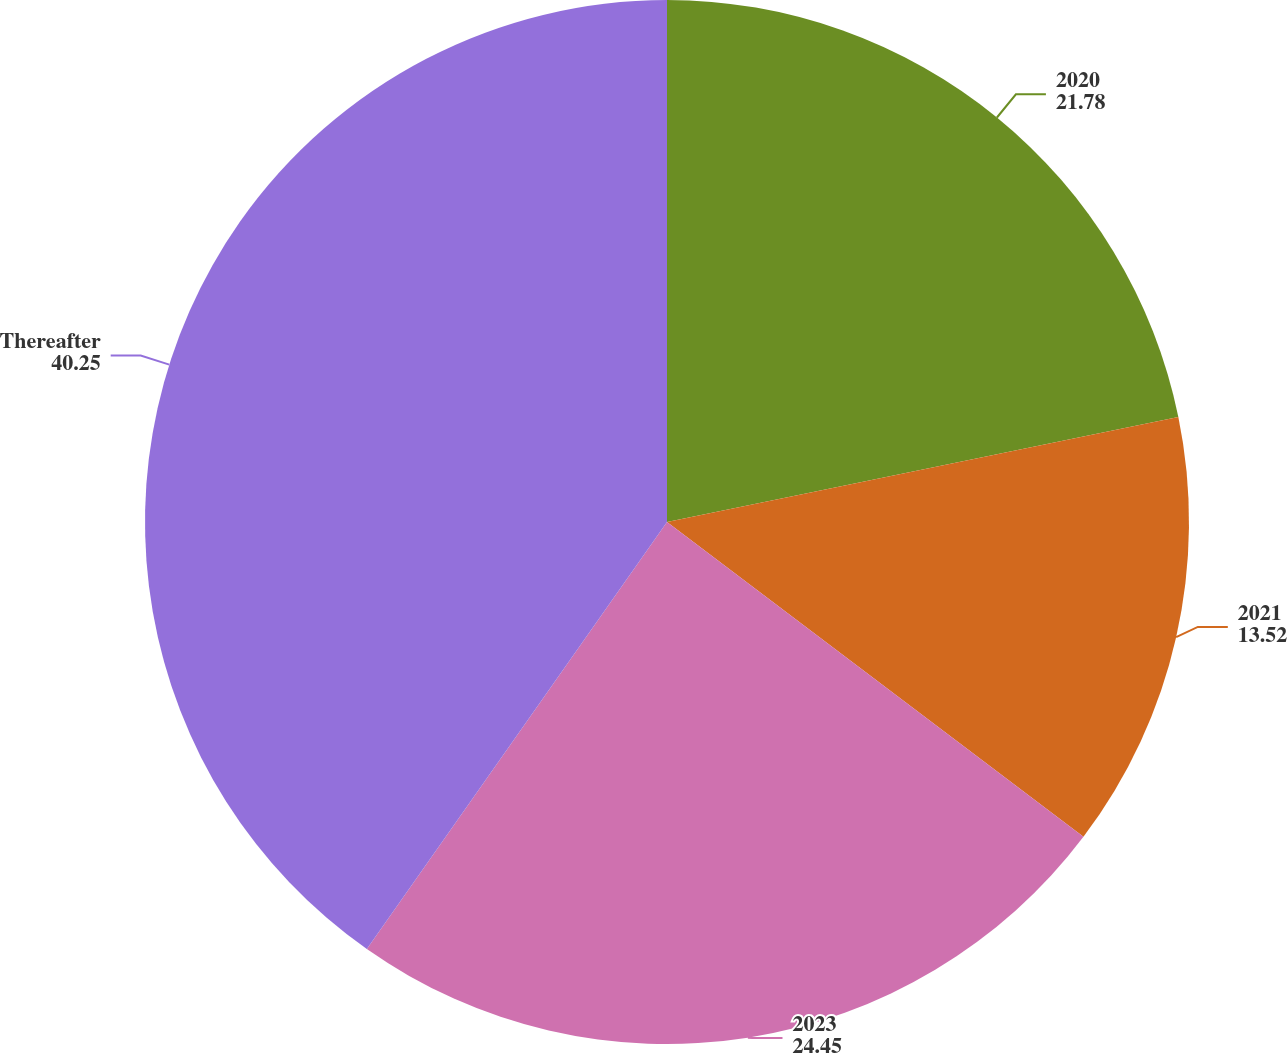Convert chart to OTSL. <chart><loc_0><loc_0><loc_500><loc_500><pie_chart><fcel>2020<fcel>2021<fcel>2023<fcel>Thereafter<nl><fcel>21.78%<fcel>13.52%<fcel>24.45%<fcel>40.25%<nl></chart> 